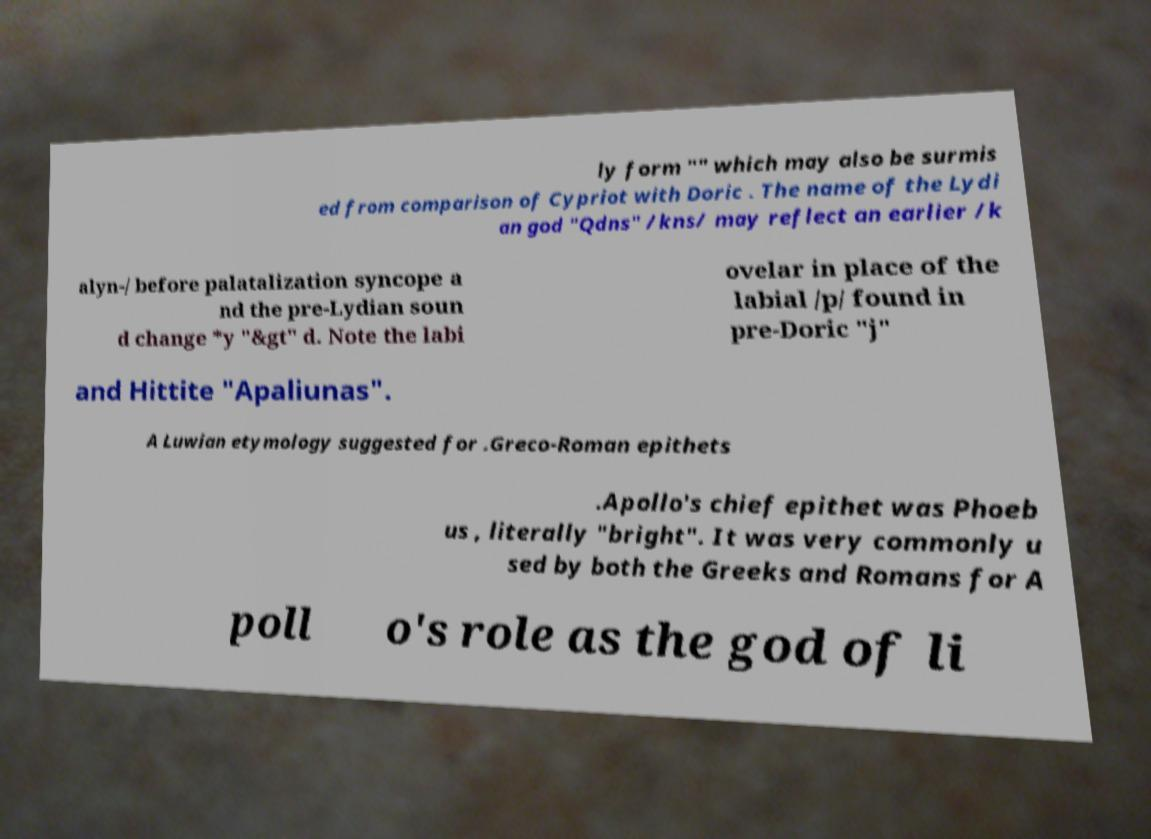What messages or text are displayed in this image? I need them in a readable, typed format. ly form "" which may also be surmis ed from comparison of Cypriot with Doric . The name of the Lydi an god "Qdns" /kns/ may reflect an earlier /k alyn-/ before palatalization syncope a nd the pre-Lydian soun d change *y "&gt" d. Note the labi ovelar in place of the labial /p/ found in pre-Doric "j" and Hittite "Apaliunas". A Luwian etymology suggested for .Greco-Roman epithets .Apollo's chief epithet was Phoeb us , literally "bright". It was very commonly u sed by both the Greeks and Romans for A poll o's role as the god of li 